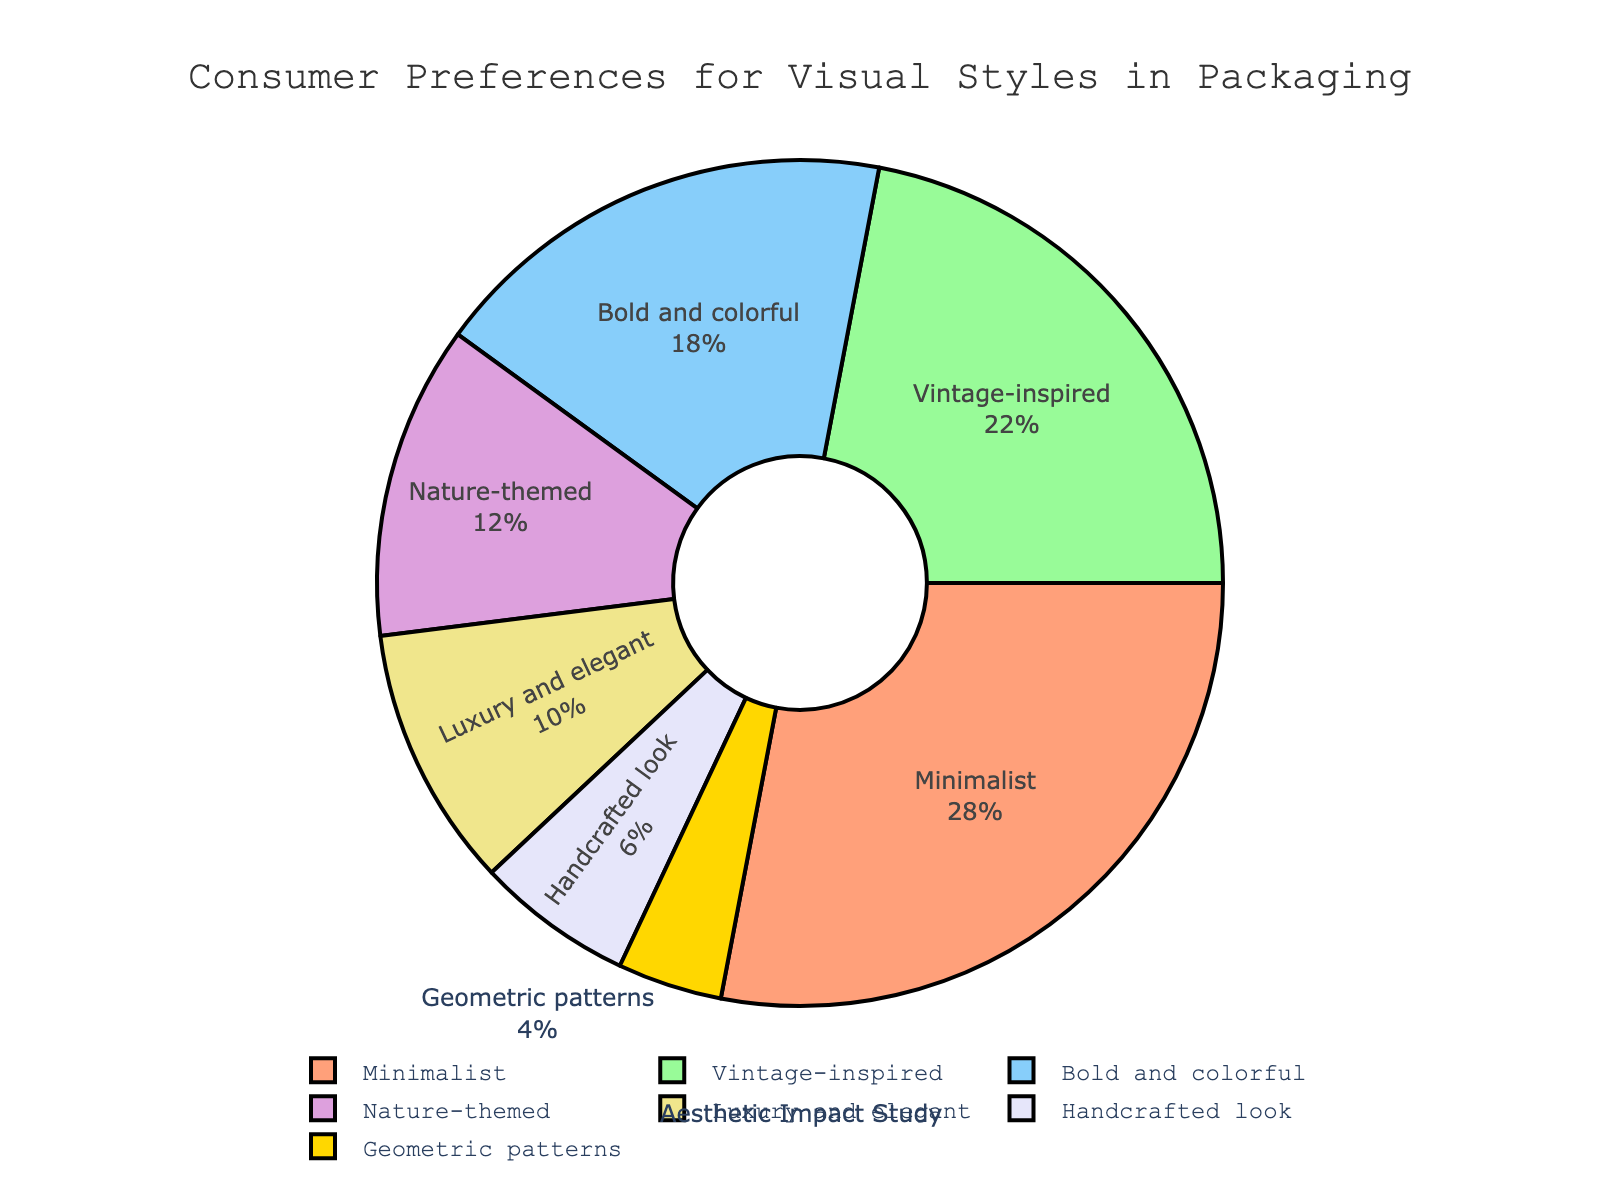what is the percentage of consumers who prefer the 'Minimalist' style? The 'Minimalist' style has a segment indicated at 28%.
Answer: 28% Between 'Bold and colorful' and 'Vintage-inspired' styles, which one is more preferred and by how much? The 'Vintage-inspired' style is preferred at 22%, whereas 'Bold and colorful' is preferred at 18%. The difference is 22% - 18% = 4%.
Answer: Vintage-inspired by 4% What is the total percentage of consumers who prefer either 'Nature-themed' or 'Luxury and elegant' styles? The percentage for 'Nature-themed' is 12% and for 'Luxury and elegant' is 10%. Summing them: 12% + 10% = 22%.
Answer: 22% Which two styles combined make up exactly 50% of consumer preferences? 'Minimalist' at 28% and 'Vintage-inspired' at 22% combine to exactly 50% (28% + 22% = 50%).
Answer: Minimalist and Vintage-inspired Which style has the smallest percentage of consumer preferences, and what is that percentage? 'Geometric patterns' has the smallest segment at 4%.
Answer: Geometric patterns with 4% By how much does the percentage for 'Minimalist' exceed the percentage for 'Handcrafted look'? 'Minimalist' is at 28% and 'Handcrafted look' is at 6%. The difference is: 28% - 6% = 22%.
Answer: 22% What is the percentage difference between the most and least preferred styles? The 'Minimalist' style is the most preferred at 28%, and 'Geometric patterns' is the least at 4%. The difference is: 28% - 4% = 24%.
Answer: 24% What is the combined percentage of preferences for styles that are below 10%? 'Handcrafted look' is 6% and 'Geometric patterns' is 4%. Combining them: 6% + 4% = 10%.
Answer: 10% Which color is used for the 'Nature-themed' segment in the pie chart? The 'Nature-themed' segment corresponds to a green-like color.
Answer: Green (or similar shade) Are there more consumers who prefer 'Luxury and elegant' or 'Handcrafted look' styles, and what is the difference? 'Luxury and elegant' is preferred by 10%, and 'Handcrafted look' by 6%. The difference is 10% - 6% = 4%.
Answer: Luxury and elegant by 4% 